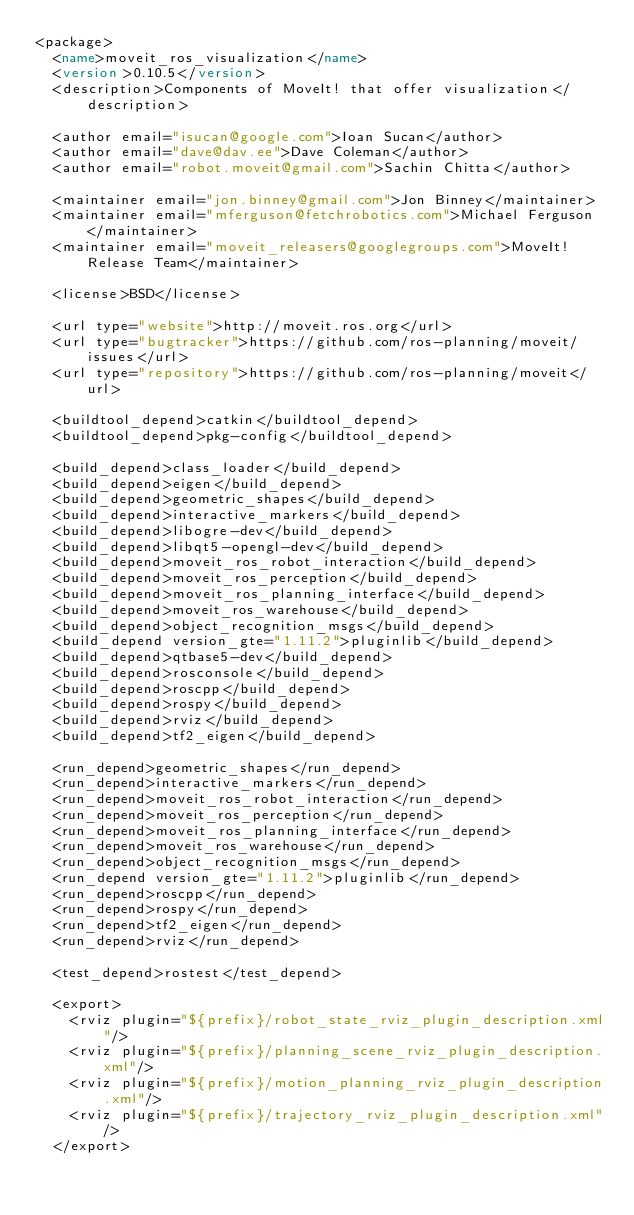Convert code to text. <code><loc_0><loc_0><loc_500><loc_500><_XML_><package>
  <name>moveit_ros_visualization</name>
  <version>0.10.5</version>
  <description>Components of MoveIt! that offer visualization</description>

  <author email="isucan@google.com">Ioan Sucan</author>
  <author email="dave@dav.ee">Dave Coleman</author>
  <author email="robot.moveit@gmail.com">Sachin Chitta</author>

  <maintainer email="jon.binney@gmail.com">Jon Binney</maintainer>
  <maintainer email="mferguson@fetchrobotics.com">Michael Ferguson</maintainer>
  <maintainer email="moveit_releasers@googlegroups.com">MoveIt! Release Team</maintainer>

  <license>BSD</license>

  <url type="website">http://moveit.ros.org</url>
  <url type="bugtracker">https://github.com/ros-planning/moveit/issues</url>
  <url type="repository">https://github.com/ros-planning/moveit</url>

  <buildtool_depend>catkin</buildtool_depend>
  <buildtool_depend>pkg-config</buildtool_depend>

  <build_depend>class_loader</build_depend>
  <build_depend>eigen</build_depend>
  <build_depend>geometric_shapes</build_depend>
  <build_depend>interactive_markers</build_depend>
  <build_depend>libogre-dev</build_depend>
  <build_depend>libqt5-opengl-dev</build_depend>
  <build_depend>moveit_ros_robot_interaction</build_depend>
  <build_depend>moveit_ros_perception</build_depend>
  <build_depend>moveit_ros_planning_interface</build_depend>
  <build_depend>moveit_ros_warehouse</build_depend>
  <build_depend>object_recognition_msgs</build_depend>
  <build_depend version_gte="1.11.2">pluginlib</build_depend>
  <build_depend>qtbase5-dev</build_depend>
  <build_depend>rosconsole</build_depend>
  <build_depend>roscpp</build_depend>
  <build_depend>rospy</build_depend>
  <build_depend>rviz</build_depend>
  <build_depend>tf2_eigen</build_depend>

  <run_depend>geometric_shapes</run_depend>
  <run_depend>interactive_markers</run_depend>
  <run_depend>moveit_ros_robot_interaction</run_depend>
  <run_depend>moveit_ros_perception</run_depend>
  <run_depend>moveit_ros_planning_interface</run_depend>
  <run_depend>moveit_ros_warehouse</run_depend>
  <run_depend>object_recognition_msgs</run_depend>
  <run_depend version_gte="1.11.2">pluginlib</run_depend>
  <run_depend>roscpp</run_depend>
  <run_depend>rospy</run_depend>
  <run_depend>tf2_eigen</run_depend>
  <run_depend>rviz</run_depend>

  <test_depend>rostest</test_depend>

  <export>
    <rviz plugin="${prefix}/robot_state_rviz_plugin_description.xml"/>
    <rviz plugin="${prefix}/planning_scene_rviz_plugin_description.xml"/>
    <rviz plugin="${prefix}/motion_planning_rviz_plugin_description.xml"/>
    <rviz plugin="${prefix}/trajectory_rviz_plugin_description.xml"/>
  </export>
</code> 